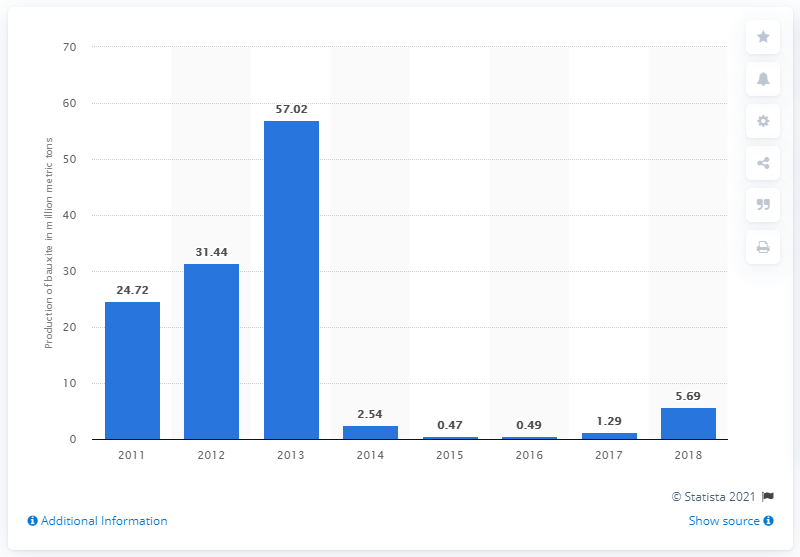Identify some key points in this picture. In 2017, the production of bauxite in Indonesia was 1.29 million metric tonnes. 